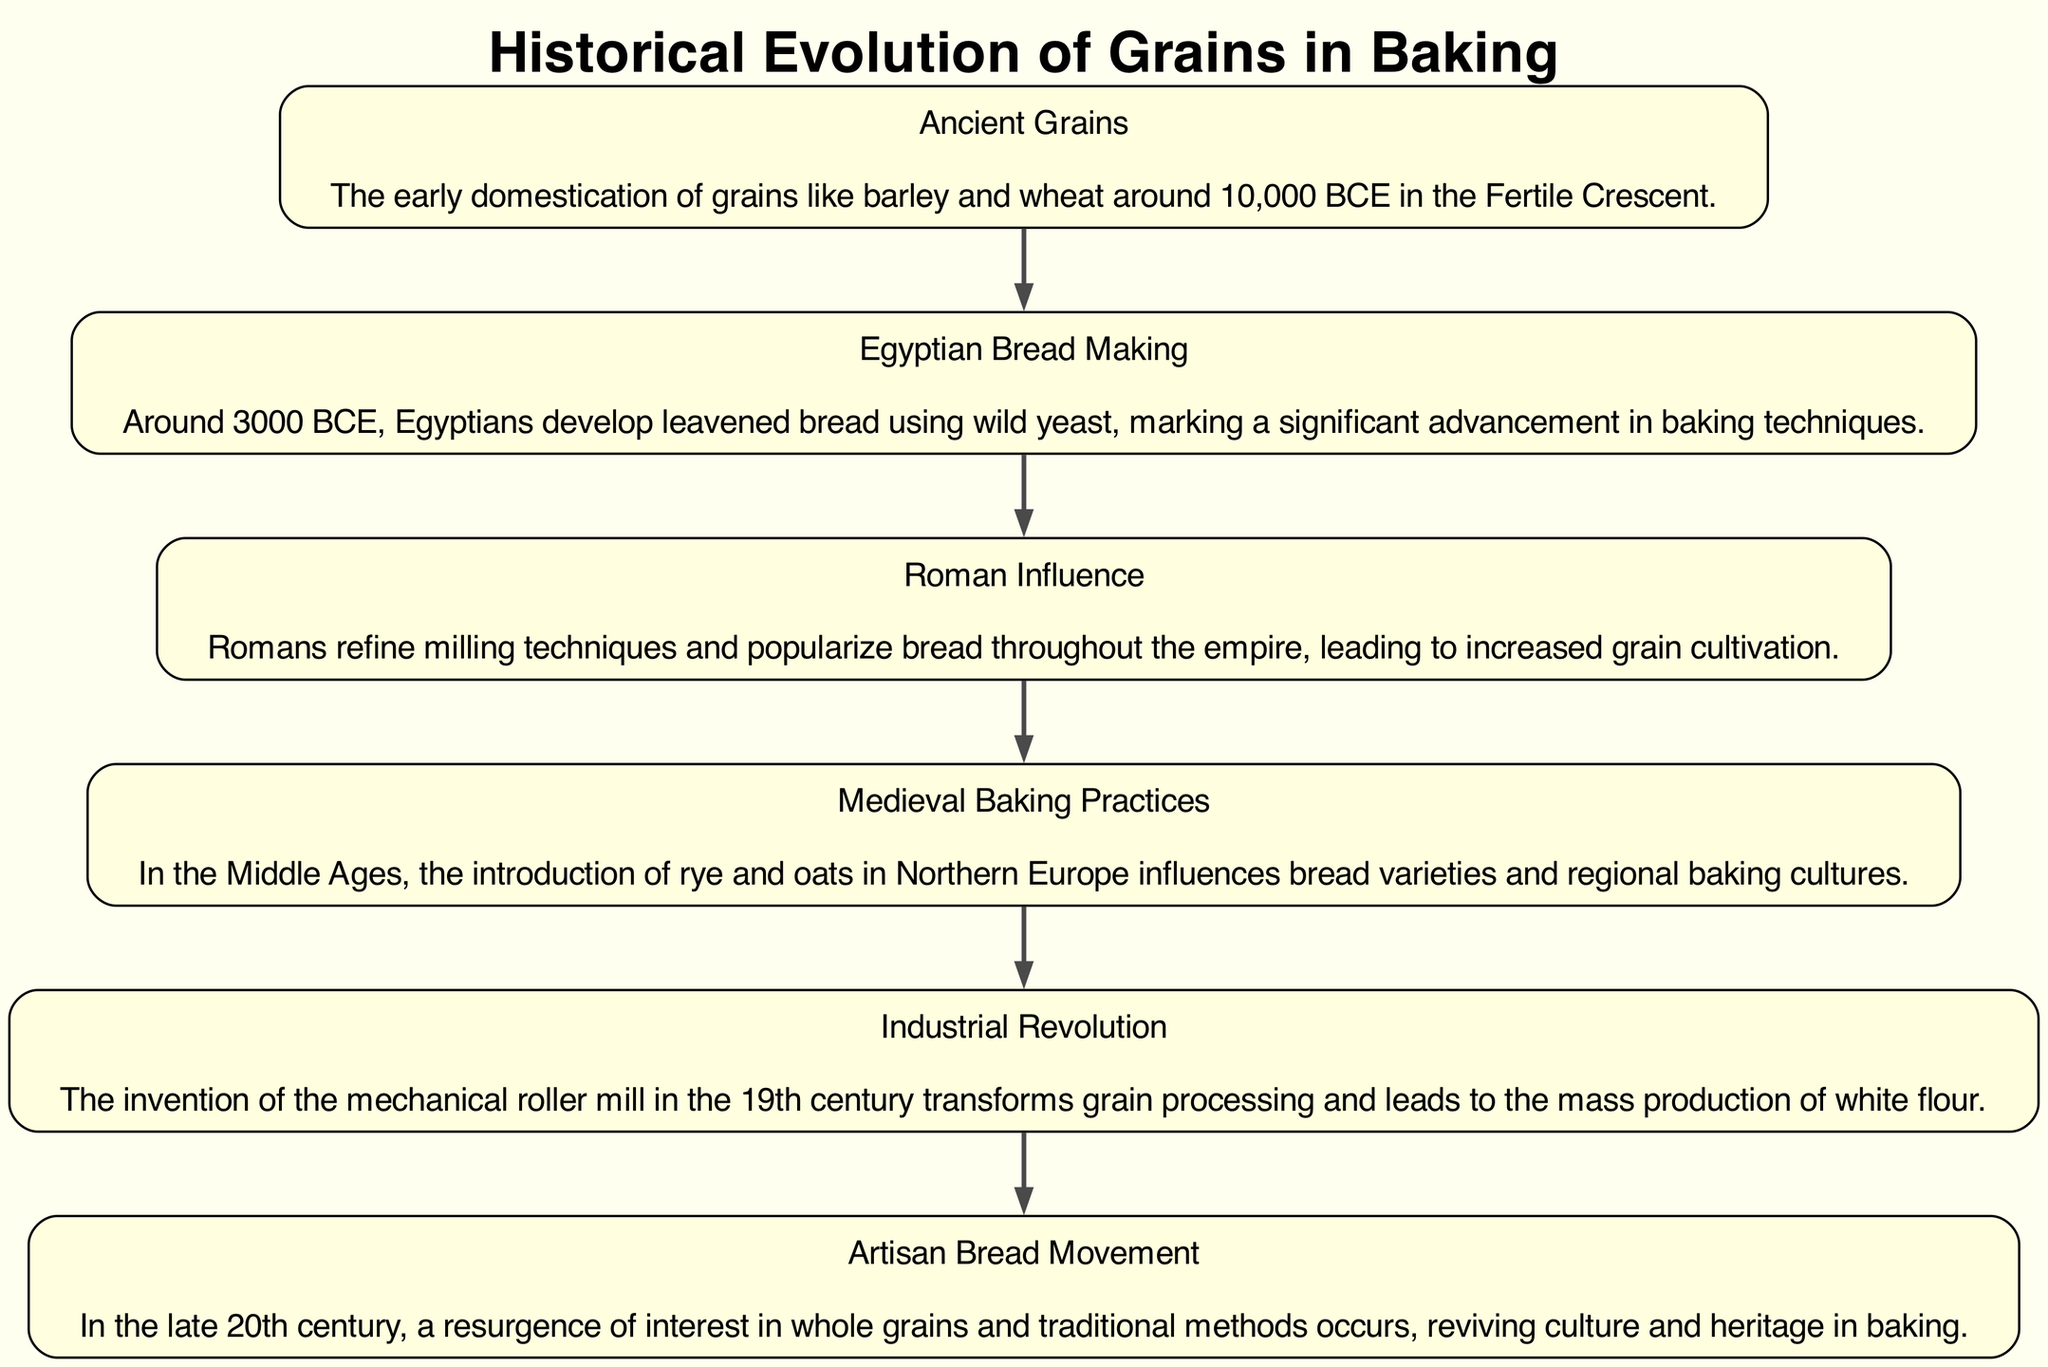What is the earliest grain mentioned in the diagram? The diagram specifies "Ancient Grains" at the beginning, describing barley and wheat as the earliest domesticated grains around 10,000 BCE.
Answer: Ancient Grains Which civilization is associated with the development of leavened bread? The diagram specifically identifies the "Egyptian Bread Making" milestone occurring around 3000 BCE, highlighting the Egyptians’ contribution to leavened bread.
Answer: Egyptians What significant technological advancement occurred during the Industrial Revolution? The "Industrial Revolution" node indicates the invention of the mechanical roller mill in the 19th century, which transformed grain processing.
Answer: Mechanical roller mill How many key milestones are depicted in the diagram? By counting the nodes in the diagram, there are six key milestones related to the historical evolution of grains in baking.
Answer: Six What grain introduction influenced bread varieties in Northern Europe? The "Medieval Baking Practices" node mentions the introduction of rye and oats, which significantly influenced bread varieties in that region.
Answer: Rye and oats Which movement in the late 20th century revived interest in traditional baking methods? The "Artisan Bread Movement" node describes a resurgence of interest in whole grains and traditional bakes in the late 20th century.
Answer: Artisan Bread Movement In which period did the Romans refine milling techniques? The "Roman Influence" milestone indicates that this refinement occurred as part of Roman advancements but does not specify an exact date, just that it was during the Roman Empire.
Answer: Roman Empire What flowed to the "Artisan Bread Movement" from earlier historical developments? The sequence in the diagram shows that the "Industrial Revolution" followed by the "Artisan Bread Movement" denotes a cultural shift back to traditional methods prompted by earlier advancements in mass production of flour.
Answer: Industrial Revolution What is the last milestone in the diagram? The final node in the flowchart is the "Artisan Bread Movement," marking it as the last milestone depicted.
Answer: Artisan Bread Movement 